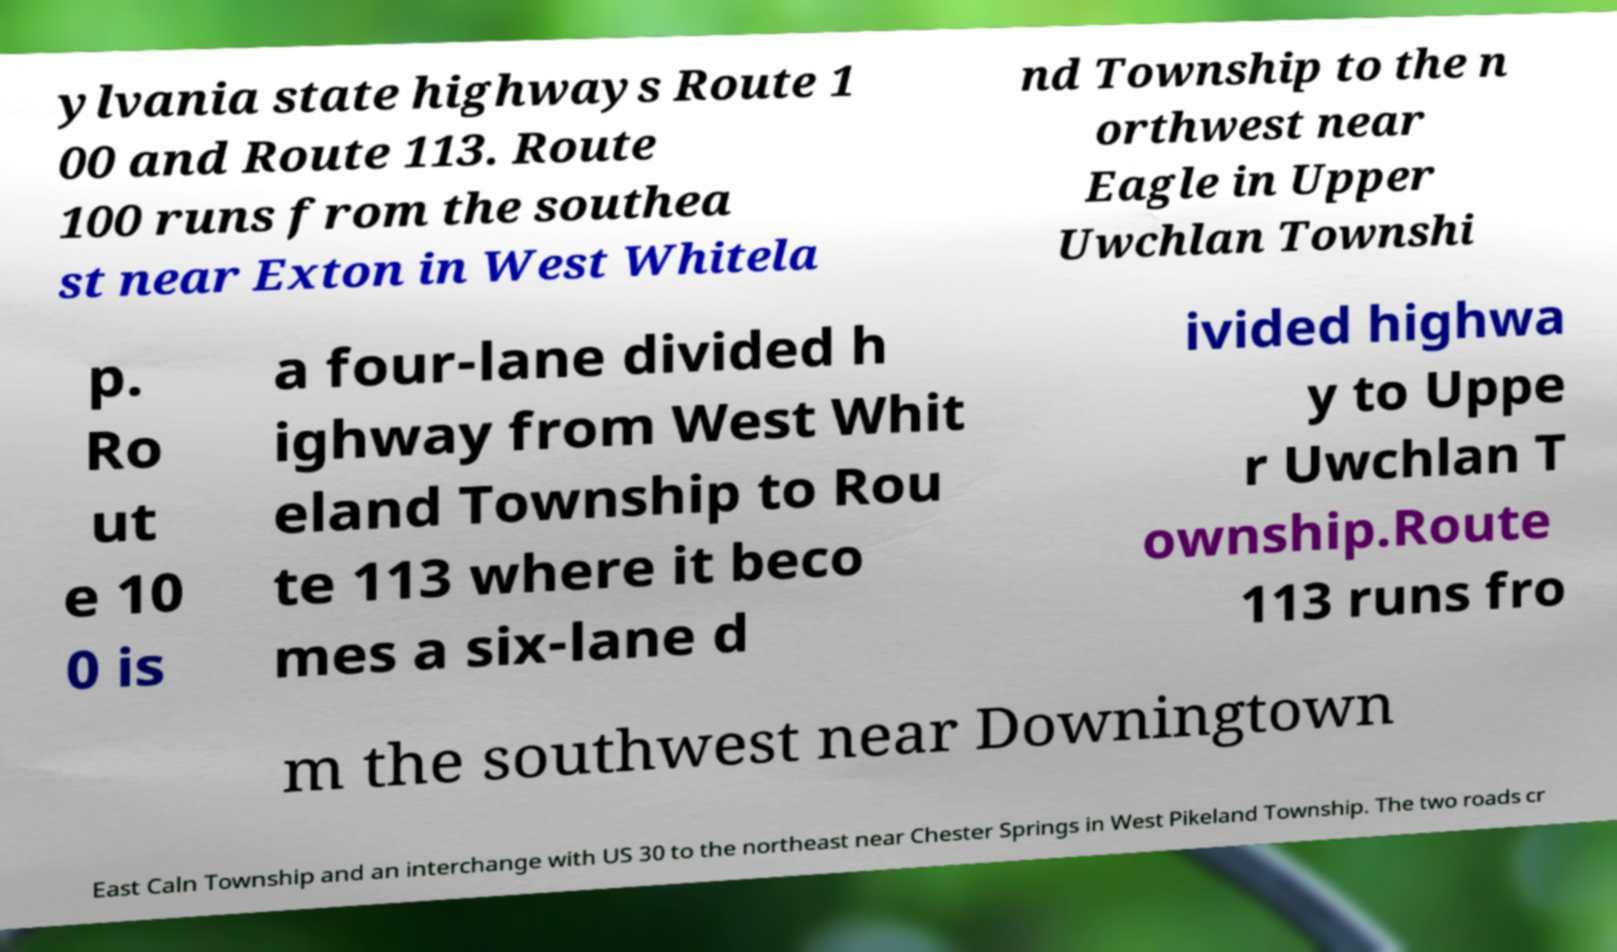Please read and relay the text visible in this image. What does it say? ylvania state highways Route 1 00 and Route 113. Route 100 runs from the southea st near Exton in West Whitela nd Township to the n orthwest near Eagle in Upper Uwchlan Townshi p. Ro ut e 10 0 is a four-lane divided h ighway from West Whit eland Township to Rou te 113 where it beco mes a six-lane d ivided highwa y to Uppe r Uwchlan T ownship.Route 113 runs fro m the southwest near Downingtown East Caln Township and an interchange with US 30 to the northeast near Chester Springs in West Pikeland Township. The two roads cr 